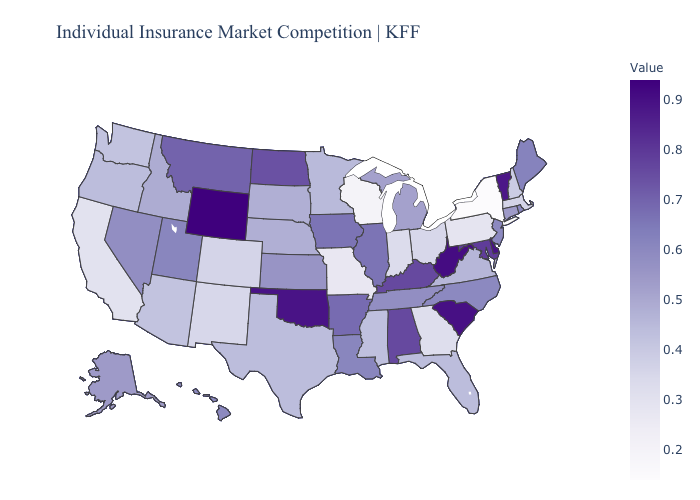Which states have the highest value in the USA?
Give a very brief answer. Wyoming. Does South Dakota have the lowest value in the MidWest?
Write a very short answer. No. Does Arizona have the highest value in the West?
Give a very brief answer. No. Which states have the lowest value in the West?
Give a very brief answer. California. Among the states that border New Mexico , does Arizona have the highest value?
Answer briefly. No. 